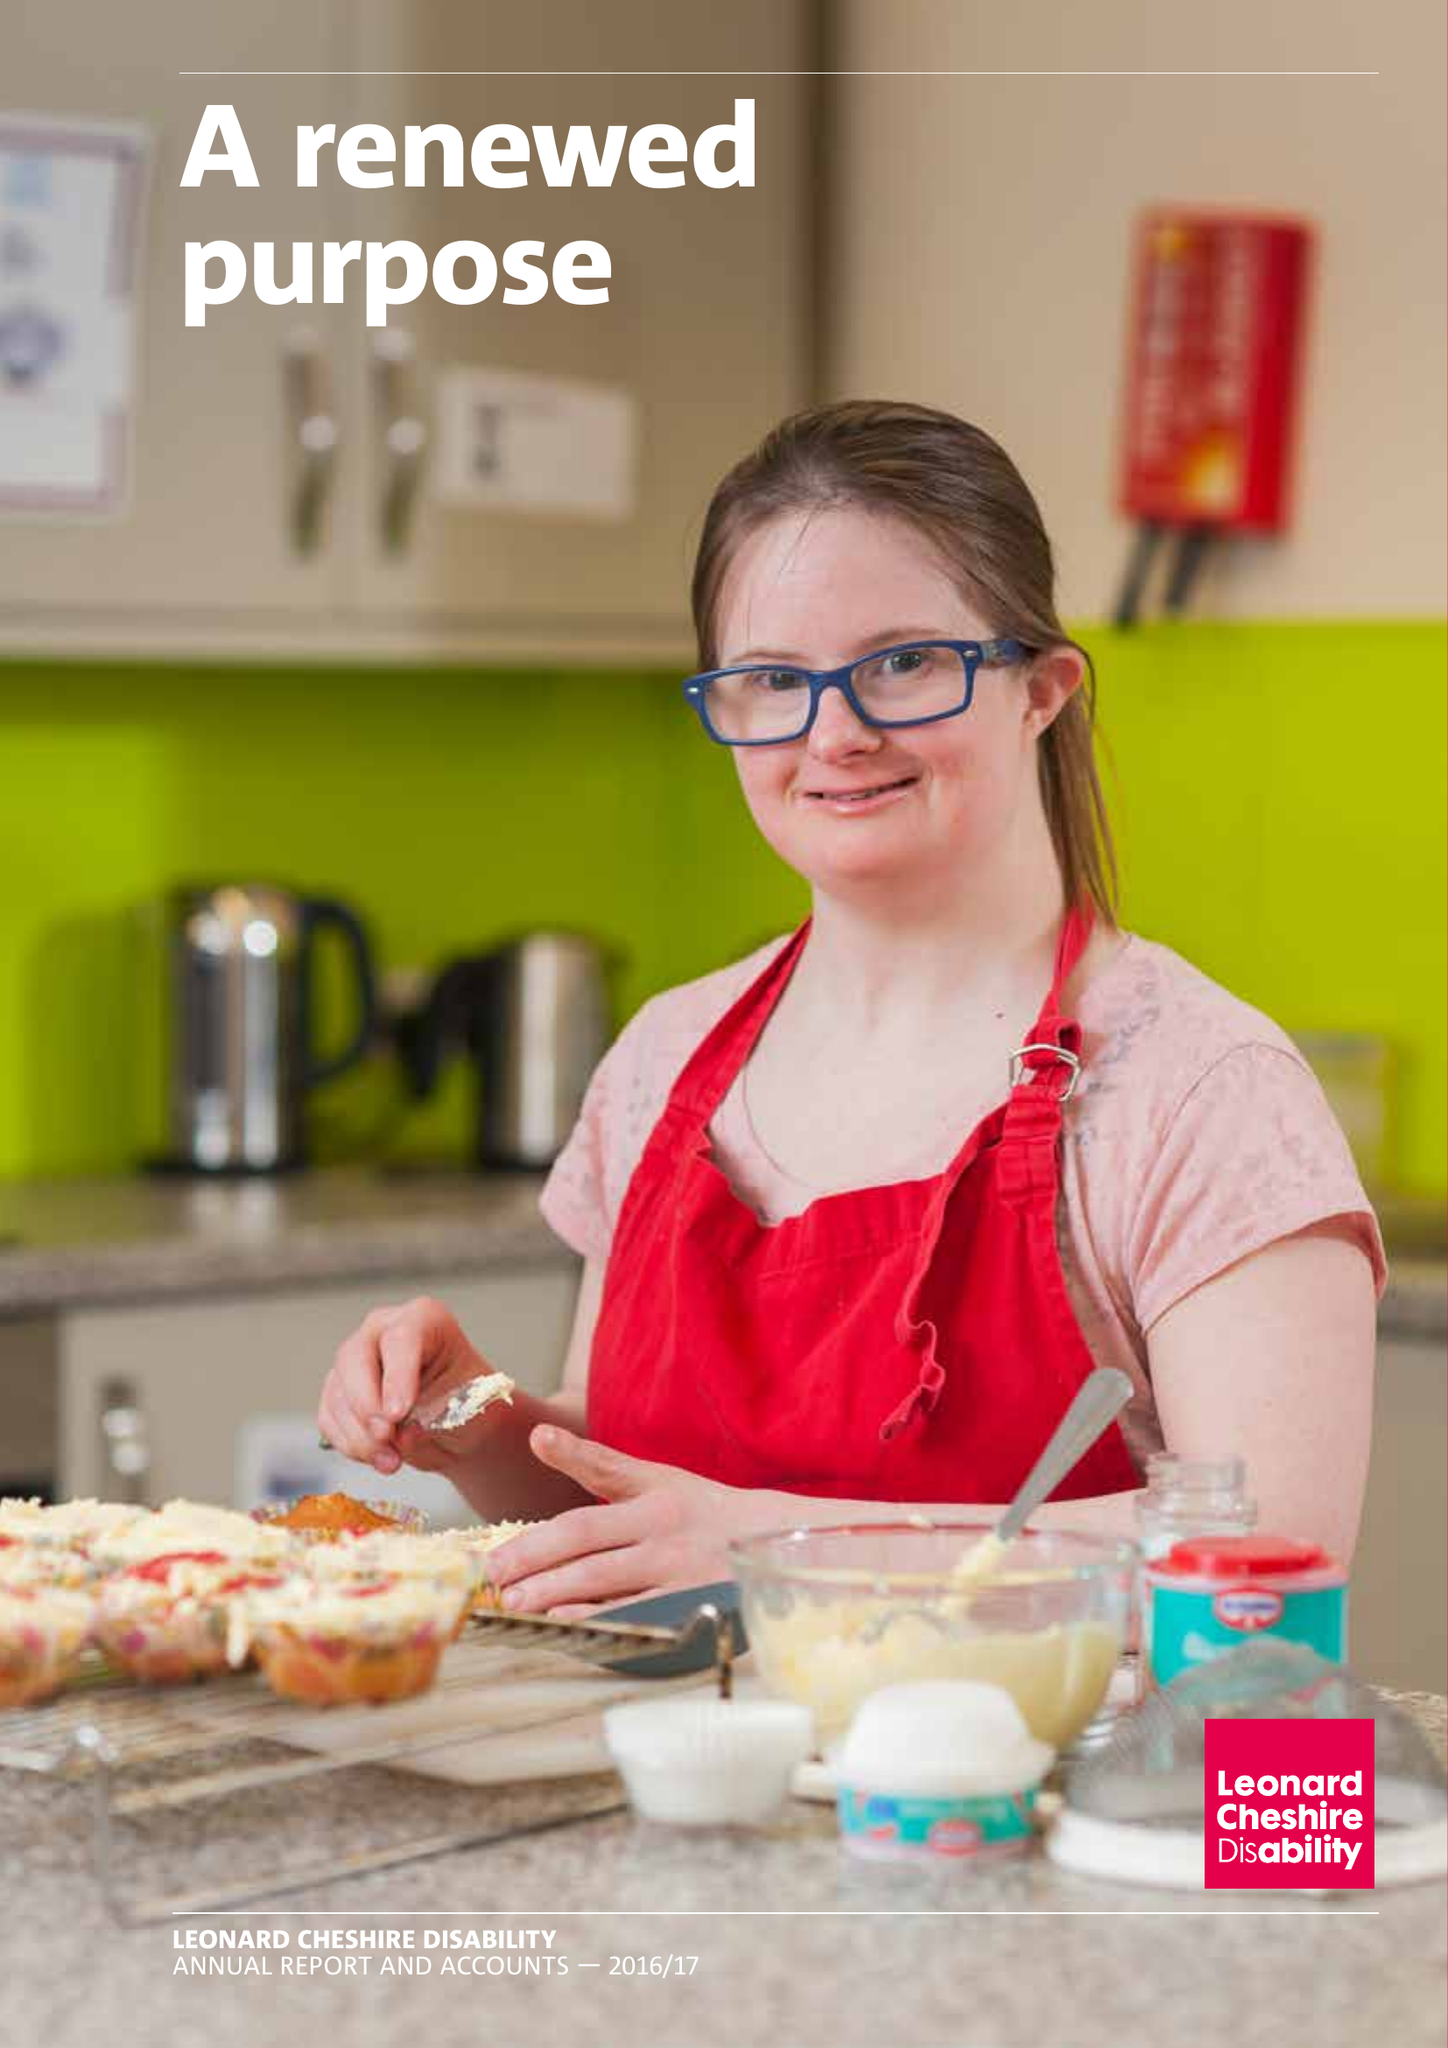What is the value for the spending_annually_in_british_pounds?
Answer the question using a single word or phrase. 160625000.00 